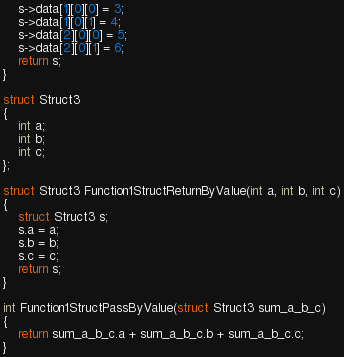Convert code to text. <code><loc_0><loc_0><loc_500><loc_500><_C_>    s->data[1][0][0] = 3;
    s->data[1][0][1] = 4;
    s->data[2][0][0] = 5;
    s->data[2][0][1] = 6;
    return s;
}

struct Struct3
{
    int a;
    int b;
    int c;
};

struct Struct3 Function1StructReturnByValue(int a, int b, int c)
{
    struct Struct3 s;
    s.a = a;
    s.b = b;
    s.c = c;
    return s;
}

int Function1StructPassByValue(struct Struct3 sum_a_b_c)
{
    return sum_a_b_c.a + sum_a_b_c.b + sum_a_b_c.c;
}
</code> 